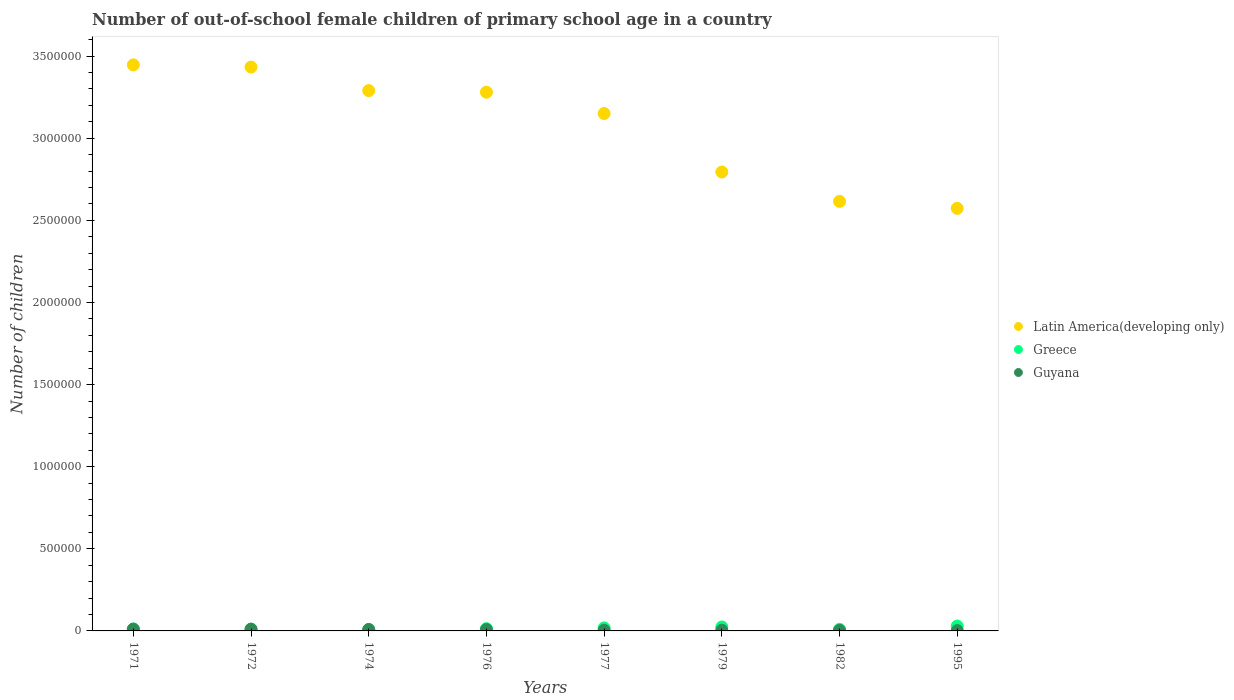Is the number of dotlines equal to the number of legend labels?
Offer a terse response. Yes. What is the number of out-of-school female children in Greece in 1971?
Keep it short and to the point. 1.16e+04. Across all years, what is the maximum number of out-of-school female children in Greece?
Ensure brevity in your answer.  2.95e+04. Across all years, what is the minimum number of out-of-school female children in Latin America(developing only)?
Provide a succinct answer. 2.57e+06. In which year was the number of out-of-school female children in Guyana maximum?
Your response must be concise. 1972. In which year was the number of out-of-school female children in Latin America(developing only) minimum?
Offer a terse response. 1995. What is the total number of out-of-school female children in Guyana in the graph?
Give a very brief answer. 5.31e+04. What is the difference between the number of out-of-school female children in Greece in 1977 and that in 1982?
Provide a short and direct response. 8815. What is the difference between the number of out-of-school female children in Guyana in 1995 and the number of out-of-school female children in Latin America(developing only) in 1977?
Your answer should be compact. -3.15e+06. What is the average number of out-of-school female children in Greece per year?
Your response must be concise. 1.56e+04. In the year 1977, what is the difference between the number of out-of-school female children in Greece and number of out-of-school female children in Latin America(developing only)?
Provide a short and direct response. -3.13e+06. What is the ratio of the number of out-of-school female children in Greece in 1974 to that in 1995?
Offer a very short reply. 0.25. Is the difference between the number of out-of-school female children in Greece in 1971 and 1972 greater than the difference between the number of out-of-school female children in Latin America(developing only) in 1971 and 1972?
Provide a short and direct response. No. What is the difference between the highest and the second highest number of out-of-school female children in Latin America(developing only)?
Make the answer very short. 1.34e+04. What is the difference between the highest and the lowest number of out-of-school female children in Latin America(developing only)?
Ensure brevity in your answer.  8.74e+05. Is the sum of the number of out-of-school female children in Greece in 1979 and 1982 greater than the maximum number of out-of-school female children in Guyana across all years?
Give a very brief answer. Yes. Is the number of out-of-school female children in Greece strictly less than the number of out-of-school female children in Guyana over the years?
Your answer should be compact. No. How many dotlines are there?
Your response must be concise. 3. What is the difference between two consecutive major ticks on the Y-axis?
Provide a short and direct response. 5.00e+05. Does the graph contain grids?
Your answer should be very brief. No. Where does the legend appear in the graph?
Offer a terse response. Center right. How many legend labels are there?
Provide a short and direct response. 3. How are the legend labels stacked?
Your answer should be compact. Vertical. What is the title of the graph?
Provide a short and direct response. Number of out-of-school female children of primary school age in a country. What is the label or title of the Y-axis?
Give a very brief answer. Number of children. What is the Number of children in Latin America(developing only) in 1971?
Your response must be concise. 3.45e+06. What is the Number of children of Greece in 1971?
Your answer should be compact. 1.16e+04. What is the Number of children of Guyana in 1971?
Your answer should be very brief. 1.09e+04. What is the Number of children in Latin America(developing only) in 1972?
Offer a very short reply. 3.43e+06. What is the Number of children in Greece in 1972?
Your answer should be very brief. 1.07e+04. What is the Number of children in Guyana in 1972?
Provide a succinct answer. 1.10e+04. What is the Number of children of Latin America(developing only) in 1974?
Offer a terse response. 3.29e+06. What is the Number of children in Greece in 1974?
Your response must be concise. 7336. What is the Number of children in Guyana in 1974?
Provide a short and direct response. 8910. What is the Number of children in Latin America(developing only) in 1976?
Your answer should be very brief. 3.28e+06. What is the Number of children of Greece in 1976?
Offer a terse response. 1.38e+04. What is the Number of children in Guyana in 1976?
Keep it short and to the point. 8456. What is the Number of children in Latin America(developing only) in 1977?
Give a very brief answer. 3.15e+06. What is the Number of children in Greece in 1977?
Keep it short and to the point. 1.83e+04. What is the Number of children of Guyana in 1977?
Keep it short and to the point. 4077. What is the Number of children in Latin America(developing only) in 1979?
Give a very brief answer. 2.79e+06. What is the Number of children in Greece in 1979?
Offer a terse response. 2.41e+04. What is the Number of children of Guyana in 1979?
Your response must be concise. 4353. What is the Number of children in Latin America(developing only) in 1982?
Provide a succinct answer. 2.62e+06. What is the Number of children of Greece in 1982?
Provide a succinct answer. 9447. What is the Number of children in Guyana in 1982?
Make the answer very short. 3656. What is the Number of children in Latin America(developing only) in 1995?
Make the answer very short. 2.57e+06. What is the Number of children in Greece in 1995?
Offer a very short reply. 2.95e+04. What is the Number of children of Guyana in 1995?
Give a very brief answer. 1838. Across all years, what is the maximum Number of children of Latin America(developing only)?
Make the answer very short. 3.45e+06. Across all years, what is the maximum Number of children of Greece?
Provide a succinct answer. 2.95e+04. Across all years, what is the maximum Number of children of Guyana?
Keep it short and to the point. 1.10e+04. Across all years, what is the minimum Number of children of Latin America(developing only)?
Offer a very short reply. 2.57e+06. Across all years, what is the minimum Number of children in Greece?
Your answer should be very brief. 7336. Across all years, what is the minimum Number of children in Guyana?
Keep it short and to the point. 1838. What is the total Number of children of Latin America(developing only) in the graph?
Your answer should be very brief. 2.46e+07. What is the total Number of children in Greece in the graph?
Provide a short and direct response. 1.25e+05. What is the total Number of children in Guyana in the graph?
Offer a very short reply. 5.31e+04. What is the difference between the Number of children of Latin America(developing only) in 1971 and that in 1972?
Offer a very short reply. 1.34e+04. What is the difference between the Number of children of Greece in 1971 and that in 1972?
Keep it short and to the point. 932. What is the difference between the Number of children in Guyana in 1971 and that in 1972?
Keep it short and to the point. -63. What is the difference between the Number of children of Latin America(developing only) in 1971 and that in 1974?
Your answer should be very brief. 1.57e+05. What is the difference between the Number of children of Greece in 1971 and that in 1974?
Offer a terse response. 4256. What is the difference between the Number of children of Guyana in 1971 and that in 1974?
Keep it short and to the point. 1980. What is the difference between the Number of children in Latin America(developing only) in 1971 and that in 1976?
Offer a very short reply. 1.66e+05. What is the difference between the Number of children of Greece in 1971 and that in 1976?
Ensure brevity in your answer.  -2198. What is the difference between the Number of children in Guyana in 1971 and that in 1976?
Offer a terse response. 2434. What is the difference between the Number of children of Latin America(developing only) in 1971 and that in 1977?
Your response must be concise. 2.96e+05. What is the difference between the Number of children of Greece in 1971 and that in 1977?
Offer a very short reply. -6670. What is the difference between the Number of children of Guyana in 1971 and that in 1977?
Make the answer very short. 6813. What is the difference between the Number of children in Latin America(developing only) in 1971 and that in 1979?
Your answer should be very brief. 6.53e+05. What is the difference between the Number of children in Greece in 1971 and that in 1979?
Keep it short and to the point. -1.25e+04. What is the difference between the Number of children in Guyana in 1971 and that in 1979?
Offer a very short reply. 6537. What is the difference between the Number of children in Latin America(developing only) in 1971 and that in 1982?
Make the answer very short. 8.31e+05. What is the difference between the Number of children of Greece in 1971 and that in 1982?
Provide a short and direct response. 2145. What is the difference between the Number of children of Guyana in 1971 and that in 1982?
Make the answer very short. 7234. What is the difference between the Number of children in Latin America(developing only) in 1971 and that in 1995?
Your answer should be compact. 8.74e+05. What is the difference between the Number of children in Greece in 1971 and that in 1995?
Ensure brevity in your answer.  -1.79e+04. What is the difference between the Number of children in Guyana in 1971 and that in 1995?
Provide a short and direct response. 9052. What is the difference between the Number of children of Latin America(developing only) in 1972 and that in 1974?
Make the answer very short. 1.43e+05. What is the difference between the Number of children of Greece in 1972 and that in 1974?
Your answer should be very brief. 3324. What is the difference between the Number of children in Guyana in 1972 and that in 1974?
Your answer should be compact. 2043. What is the difference between the Number of children in Latin America(developing only) in 1972 and that in 1976?
Your answer should be very brief. 1.53e+05. What is the difference between the Number of children of Greece in 1972 and that in 1976?
Provide a succinct answer. -3130. What is the difference between the Number of children in Guyana in 1972 and that in 1976?
Your response must be concise. 2497. What is the difference between the Number of children of Latin America(developing only) in 1972 and that in 1977?
Provide a succinct answer. 2.83e+05. What is the difference between the Number of children in Greece in 1972 and that in 1977?
Keep it short and to the point. -7602. What is the difference between the Number of children in Guyana in 1972 and that in 1977?
Give a very brief answer. 6876. What is the difference between the Number of children of Latin America(developing only) in 1972 and that in 1979?
Give a very brief answer. 6.39e+05. What is the difference between the Number of children of Greece in 1972 and that in 1979?
Offer a terse response. -1.35e+04. What is the difference between the Number of children in Guyana in 1972 and that in 1979?
Ensure brevity in your answer.  6600. What is the difference between the Number of children in Latin America(developing only) in 1972 and that in 1982?
Keep it short and to the point. 8.18e+05. What is the difference between the Number of children of Greece in 1972 and that in 1982?
Ensure brevity in your answer.  1213. What is the difference between the Number of children in Guyana in 1972 and that in 1982?
Ensure brevity in your answer.  7297. What is the difference between the Number of children of Latin America(developing only) in 1972 and that in 1995?
Your response must be concise. 8.60e+05. What is the difference between the Number of children in Greece in 1972 and that in 1995?
Make the answer very short. -1.88e+04. What is the difference between the Number of children in Guyana in 1972 and that in 1995?
Offer a terse response. 9115. What is the difference between the Number of children in Latin America(developing only) in 1974 and that in 1976?
Give a very brief answer. 9686. What is the difference between the Number of children of Greece in 1974 and that in 1976?
Give a very brief answer. -6454. What is the difference between the Number of children in Guyana in 1974 and that in 1976?
Your answer should be very brief. 454. What is the difference between the Number of children in Latin America(developing only) in 1974 and that in 1977?
Make the answer very short. 1.39e+05. What is the difference between the Number of children in Greece in 1974 and that in 1977?
Provide a short and direct response. -1.09e+04. What is the difference between the Number of children of Guyana in 1974 and that in 1977?
Give a very brief answer. 4833. What is the difference between the Number of children in Latin America(developing only) in 1974 and that in 1979?
Your response must be concise. 4.96e+05. What is the difference between the Number of children of Greece in 1974 and that in 1979?
Make the answer very short. -1.68e+04. What is the difference between the Number of children in Guyana in 1974 and that in 1979?
Give a very brief answer. 4557. What is the difference between the Number of children of Latin America(developing only) in 1974 and that in 1982?
Your response must be concise. 6.75e+05. What is the difference between the Number of children in Greece in 1974 and that in 1982?
Your response must be concise. -2111. What is the difference between the Number of children of Guyana in 1974 and that in 1982?
Offer a very short reply. 5254. What is the difference between the Number of children in Latin America(developing only) in 1974 and that in 1995?
Offer a terse response. 7.17e+05. What is the difference between the Number of children in Greece in 1974 and that in 1995?
Give a very brief answer. -2.22e+04. What is the difference between the Number of children of Guyana in 1974 and that in 1995?
Your answer should be very brief. 7072. What is the difference between the Number of children of Latin America(developing only) in 1976 and that in 1977?
Your answer should be very brief. 1.30e+05. What is the difference between the Number of children of Greece in 1976 and that in 1977?
Provide a short and direct response. -4472. What is the difference between the Number of children of Guyana in 1976 and that in 1977?
Make the answer very short. 4379. What is the difference between the Number of children in Latin America(developing only) in 1976 and that in 1979?
Make the answer very short. 4.86e+05. What is the difference between the Number of children of Greece in 1976 and that in 1979?
Your response must be concise. -1.03e+04. What is the difference between the Number of children in Guyana in 1976 and that in 1979?
Your answer should be compact. 4103. What is the difference between the Number of children in Latin America(developing only) in 1976 and that in 1982?
Provide a succinct answer. 6.65e+05. What is the difference between the Number of children in Greece in 1976 and that in 1982?
Your answer should be very brief. 4343. What is the difference between the Number of children in Guyana in 1976 and that in 1982?
Keep it short and to the point. 4800. What is the difference between the Number of children of Latin America(developing only) in 1976 and that in 1995?
Offer a terse response. 7.07e+05. What is the difference between the Number of children in Greece in 1976 and that in 1995?
Your answer should be compact. -1.57e+04. What is the difference between the Number of children of Guyana in 1976 and that in 1995?
Your response must be concise. 6618. What is the difference between the Number of children in Latin America(developing only) in 1977 and that in 1979?
Give a very brief answer. 3.56e+05. What is the difference between the Number of children in Greece in 1977 and that in 1979?
Your answer should be very brief. -5863. What is the difference between the Number of children of Guyana in 1977 and that in 1979?
Keep it short and to the point. -276. What is the difference between the Number of children in Latin America(developing only) in 1977 and that in 1982?
Ensure brevity in your answer.  5.35e+05. What is the difference between the Number of children in Greece in 1977 and that in 1982?
Offer a terse response. 8815. What is the difference between the Number of children in Guyana in 1977 and that in 1982?
Provide a short and direct response. 421. What is the difference between the Number of children of Latin America(developing only) in 1977 and that in 1995?
Give a very brief answer. 5.78e+05. What is the difference between the Number of children in Greece in 1977 and that in 1995?
Provide a short and direct response. -1.12e+04. What is the difference between the Number of children of Guyana in 1977 and that in 1995?
Ensure brevity in your answer.  2239. What is the difference between the Number of children in Latin America(developing only) in 1979 and that in 1982?
Your response must be concise. 1.79e+05. What is the difference between the Number of children of Greece in 1979 and that in 1982?
Keep it short and to the point. 1.47e+04. What is the difference between the Number of children of Guyana in 1979 and that in 1982?
Your answer should be very brief. 697. What is the difference between the Number of children of Latin America(developing only) in 1979 and that in 1995?
Your response must be concise. 2.21e+05. What is the difference between the Number of children of Greece in 1979 and that in 1995?
Offer a very short reply. -5365. What is the difference between the Number of children of Guyana in 1979 and that in 1995?
Give a very brief answer. 2515. What is the difference between the Number of children of Latin America(developing only) in 1982 and that in 1995?
Provide a short and direct response. 4.25e+04. What is the difference between the Number of children in Greece in 1982 and that in 1995?
Ensure brevity in your answer.  -2.00e+04. What is the difference between the Number of children in Guyana in 1982 and that in 1995?
Provide a succinct answer. 1818. What is the difference between the Number of children of Latin America(developing only) in 1971 and the Number of children of Greece in 1972?
Provide a short and direct response. 3.44e+06. What is the difference between the Number of children in Latin America(developing only) in 1971 and the Number of children in Guyana in 1972?
Your response must be concise. 3.44e+06. What is the difference between the Number of children of Greece in 1971 and the Number of children of Guyana in 1972?
Your response must be concise. 639. What is the difference between the Number of children in Latin America(developing only) in 1971 and the Number of children in Greece in 1974?
Offer a very short reply. 3.44e+06. What is the difference between the Number of children in Latin America(developing only) in 1971 and the Number of children in Guyana in 1974?
Ensure brevity in your answer.  3.44e+06. What is the difference between the Number of children of Greece in 1971 and the Number of children of Guyana in 1974?
Provide a succinct answer. 2682. What is the difference between the Number of children in Latin America(developing only) in 1971 and the Number of children in Greece in 1976?
Your response must be concise. 3.43e+06. What is the difference between the Number of children in Latin America(developing only) in 1971 and the Number of children in Guyana in 1976?
Offer a terse response. 3.44e+06. What is the difference between the Number of children of Greece in 1971 and the Number of children of Guyana in 1976?
Provide a short and direct response. 3136. What is the difference between the Number of children in Latin America(developing only) in 1971 and the Number of children in Greece in 1977?
Provide a succinct answer. 3.43e+06. What is the difference between the Number of children in Latin America(developing only) in 1971 and the Number of children in Guyana in 1977?
Keep it short and to the point. 3.44e+06. What is the difference between the Number of children in Greece in 1971 and the Number of children in Guyana in 1977?
Your response must be concise. 7515. What is the difference between the Number of children in Latin America(developing only) in 1971 and the Number of children in Greece in 1979?
Your answer should be compact. 3.42e+06. What is the difference between the Number of children in Latin America(developing only) in 1971 and the Number of children in Guyana in 1979?
Provide a succinct answer. 3.44e+06. What is the difference between the Number of children in Greece in 1971 and the Number of children in Guyana in 1979?
Keep it short and to the point. 7239. What is the difference between the Number of children in Latin America(developing only) in 1971 and the Number of children in Greece in 1982?
Offer a very short reply. 3.44e+06. What is the difference between the Number of children in Latin America(developing only) in 1971 and the Number of children in Guyana in 1982?
Give a very brief answer. 3.44e+06. What is the difference between the Number of children of Greece in 1971 and the Number of children of Guyana in 1982?
Provide a succinct answer. 7936. What is the difference between the Number of children of Latin America(developing only) in 1971 and the Number of children of Greece in 1995?
Make the answer very short. 3.42e+06. What is the difference between the Number of children in Latin America(developing only) in 1971 and the Number of children in Guyana in 1995?
Your answer should be very brief. 3.45e+06. What is the difference between the Number of children in Greece in 1971 and the Number of children in Guyana in 1995?
Your answer should be very brief. 9754. What is the difference between the Number of children of Latin America(developing only) in 1972 and the Number of children of Greece in 1974?
Ensure brevity in your answer.  3.43e+06. What is the difference between the Number of children of Latin America(developing only) in 1972 and the Number of children of Guyana in 1974?
Offer a very short reply. 3.42e+06. What is the difference between the Number of children in Greece in 1972 and the Number of children in Guyana in 1974?
Ensure brevity in your answer.  1750. What is the difference between the Number of children in Latin America(developing only) in 1972 and the Number of children in Greece in 1976?
Offer a very short reply. 3.42e+06. What is the difference between the Number of children of Latin America(developing only) in 1972 and the Number of children of Guyana in 1976?
Ensure brevity in your answer.  3.43e+06. What is the difference between the Number of children of Greece in 1972 and the Number of children of Guyana in 1976?
Provide a short and direct response. 2204. What is the difference between the Number of children of Latin America(developing only) in 1972 and the Number of children of Greece in 1977?
Your answer should be compact. 3.42e+06. What is the difference between the Number of children in Latin America(developing only) in 1972 and the Number of children in Guyana in 1977?
Keep it short and to the point. 3.43e+06. What is the difference between the Number of children in Greece in 1972 and the Number of children in Guyana in 1977?
Keep it short and to the point. 6583. What is the difference between the Number of children in Latin America(developing only) in 1972 and the Number of children in Greece in 1979?
Offer a terse response. 3.41e+06. What is the difference between the Number of children in Latin America(developing only) in 1972 and the Number of children in Guyana in 1979?
Ensure brevity in your answer.  3.43e+06. What is the difference between the Number of children in Greece in 1972 and the Number of children in Guyana in 1979?
Provide a short and direct response. 6307. What is the difference between the Number of children in Latin America(developing only) in 1972 and the Number of children in Greece in 1982?
Offer a terse response. 3.42e+06. What is the difference between the Number of children in Latin America(developing only) in 1972 and the Number of children in Guyana in 1982?
Provide a succinct answer. 3.43e+06. What is the difference between the Number of children in Greece in 1972 and the Number of children in Guyana in 1982?
Your answer should be very brief. 7004. What is the difference between the Number of children of Latin America(developing only) in 1972 and the Number of children of Greece in 1995?
Provide a succinct answer. 3.40e+06. What is the difference between the Number of children in Latin America(developing only) in 1972 and the Number of children in Guyana in 1995?
Provide a succinct answer. 3.43e+06. What is the difference between the Number of children in Greece in 1972 and the Number of children in Guyana in 1995?
Your response must be concise. 8822. What is the difference between the Number of children of Latin America(developing only) in 1974 and the Number of children of Greece in 1976?
Give a very brief answer. 3.28e+06. What is the difference between the Number of children in Latin America(developing only) in 1974 and the Number of children in Guyana in 1976?
Your answer should be compact. 3.28e+06. What is the difference between the Number of children of Greece in 1974 and the Number of children of Guyana in 1976?
Offer a terse response. -1120. What is the difference between the Number of children of Latin America(developing only) in 1974 and the Number of children of Greece in 1977?
Ensure brevity in your answer.  3.27e+06. What is the difference between the Number of children of Latin America(developing only) in 1974 and the Number of children of Guyana in 1977?
Your answer should be compact. 3.29e+06. What is the difference between the Number of children in Greece in 1974 and the Number of children in Guyana in 1977?
Provide a succinct answer. 3259. What is the difference between the Number of children in Latin America(developing only) in 1974 and the Number of children in Greece in 1979?
Your answer should be very brief. 3.27e+06. What is the difference between the Number of children in Latin America(developing only) in 1974 and the Number of children in Guyana in 1979?
Provide a succinct answer. 3.29e+06. What is the difference between the Number of children in Greece in 1974 and the Number of children in Guyana in 1979?
Provide a short and direct response. 2983. What is the difference between the Number of children of Latin America(developing only) in 1974 and the Number of children of Greece in 1982?
Provide a short and direct response. 3.28e+06. What is the difference between the Number of children of Latin America(developing only) in 1974 and the Number of children of Guyana in 1982?
Offer a very short reply. 3.29e+06. What is the difference between the Number of children in Greece in 1974 and the Number of children in Guyana in 1982?
Your answer should be compact. 3680. What is the difference between the Number of children in Latin America(developing only) in 1974 and the Number of children in Greece in 1995?
Offer a very short reply. 3.26e+06. What is the difference between the Number of children in Latin America(developing only) in 1974 and the Number of children in Guyana in 1995?
Keep it short and to the point. 3.29e+06. What is the difference between the Number of children in Greece in 1974 and the Number of children in Guyana in 1995?
Your answer should be compact. 5498. What is the difference between the Number of children in Latin America(developing only) in 1976 and the Number of children in Greece in 1977?
Provide a short and direct response. 3.26e+06. What is the difference between the Number of children of Latin America(developing only) in 1976 and the Number of children of Guyana in 1977?
Make the answer very short. 3.28e+06. What is the difference between the Number of children of Greece in 1976 and the Number of children of Guyana in 1977?
Your answer should be compact. 9713. What is the difference between the Number of children of Latin America(developing only) in 1976 and the Number of children of Greece in 1979?
Keep it short and to the point. 3.26e+06. What is the difference between the Number of children of Latin America(developing only) in 1976 and the Number of children of Guyana in 1979?
Your answer should be very brief. 3.28e+06. What is the difference between the Number of children of Greece in 1976 and the Number of children of Guyana in 1979?
Provide a short and direct response. 9437. What is the difference between the Number of children in Latin America(developing only) in 1976 and the Number of children in Greece in 1982?
Give a very brief answer. 3.27e+06. What is the difference between the Number of children of Latin America(developing only) in 1976 and the Number of children of Guyana in 1982?
Keep it short and to the point. 3.28e+06. What is the difference between the Number of children in Greece in 1976 and the Number of children in Guyana in 1982?
Offer a very short reply. 1.01e+04. What is the difference between the Number of children in Latin America(developing only) in 1976 and the Number of children in Greece in 1995?
Your response must be concise. 3.25e+06. What is the difference between the Number of children of Latin America(developing only) in 1976 and the Number of children of Guyana in 1995?
Ensure brevity in your answer.  3.28e+06. What is the difference between the Number of children of Greece in 1976 and the Number of children of Guyana in 1995?
Provide a succinct answer. 1.20e+04. What is the difference between the Number of children of Latin America(developing only) in 1977 and the Number of children of Greece in 1979?
Your answer should be very brief. 3.13e+06. What is the difference between the Number of children of Latin America(developing only) in 1977 and the Number of children of Guyana in 1979?
Provide a succinct answer. 3.15e+06. What is the difference between the Number of children in Greece in 1977 and the Number of children in Guyana in 1979?
Make the answer very short. 1.39e+04. What is the difference between the Number of children of Latin America(developing only) in 1977 and the Number of children of Greece in 1982?
Ensure brevity in your answer.  3.14e+06. What is the difference between the Number of children in Latin America(developing only) in 1977 and the Number of children in Guyana in 1982?
Your answer should be very brief. 3.15e+06. What is the difference between the Number of children of Greece in 1977 and the Number of children of Guyana in 1982?
Your response must be concise. 1.46e+04. What is the difference between the Number of children in Latin America(developing only) in 1977 and the Number of children in Greece in 1995?
Your answer should be very brief. 3.12e+06. What is the difference between the Number of children in Latin America(developing only) in 1977 and the Number of children in Guyana in 1995?
Offer a terse response. 3.15e+06. What is the difference between the Number of children of Greece in 1977 and the Number of children of Guyana in 1995?
Make the answer very short. 1.64e+04. What is the difference between the Number of children of Latin America(developing only) in 1979 and the Number of children of Greece in 1982?
Provide a short and direct response. 2.78e+06. What is the difference between the Number of children in Latin America(developing only) in 1979 and the Number of children in Guyana in 1982?
Provide a short and direct response. 2.79e+06. What is the difference between the Number of children in Greece in 1979 and the Number of children in Guyana in 1982?
Offer a very short reply. 2.05e+04. What is the difference between the Number of children in Latin America(developing only) in 1979 and the Number of children in Greece in 1995?
Keep it short and to the point. 2.76e+06. What is the difference between the Number of children in Latin America(developing only) in 1979 and the Number of children in Guyana in 1995?
Your response must be concise. 2.79e+06. What is the difference between the Number of children of Greece in 1979 and the Number of children of Guyana in 1995?
Make the answer very short. 2.23e+04. What is the difference between the Number of children of Latin America(developing only) in 1982 and the Number of children of Greece in 1995?
Your answer should be compact. 2.59e+06. What is the difference between the Number of children of Latin America(developing only) in 1982 and the Number of children of Guyana in 1995?
Provide a succinct answer. 2.61e+06. What is the difference between the Number of children of Greece in 1982 and the Number of children of Guyana in 1995?
Your response must be concise. 7609. What is the average Number of children in Latin America(developing only) per year?
Your answer should be compact. 3.07e+06. What is the average Number of children in Greece per year?
Provide a short and direct response. 1.56e+04. What is the average Number of children in Guyana per year?
Your response must be concise. 6641.62. In the year 1971, what is the difference between the Number of children in Latin America(developing only) and Number of children in Greece?
Your answer should be compact. 3.44e+06. In the year 1971, what is the difference between the Number of children in Latin America(developing only) and Number of children in Guyana?
Provide a succinct answer. 3.44e+06. In the year 1971, what is the difference between the Number of children in Greece and Number of children in Guyana?
Ensure brevity in your answer.  702. In the year 1972, what is the difference between the Number of children in Latin America(developing only) and Number of children in Greece?
Make the answer very short. 3.42e+06. In the year 1972, what is the difference between the Number of children in Latin America(developing only) and Number of children in Guyana?
Offer a very short reply. 3.42e+06. In the year 1972, what is the difference between the Number of children of Greece and Number of children of Guyana?
Ensure brevity in your answer.  -293. In the year 1974, what is the difference between the Number of children of Latin America(developing only) and Number of children of Greece?
Make the answer very short. 3.28e+06. In the year 1974, what is the difference between the Number of children in Latin America(developing only) and Number of children in Guyana?
Provide a short and direct response. 3.28e+06. In the year 1974, what is the difference between the Number of children in Greece and Number of children in Guyana?
Offer a terse response. -1574. In the year 1976, what is the difference between the Number of children of Latin America(developing only) and Number of children of Greece?
Your answer should be very brief. 3.27e+06. In the year 1976, what is the difference between the Number of children in Latin America(developing only) and Number of children in Guyana?
Your answer should be compact. 3.27e+06. In the year 1976, what is the difference between the Number of children in Greece and Number of children in Guyana?
Your answer should be very brief. 5334. In the year 1977, what is the difference between the Number of children of Latin America(developing only) and Number of children of Greece?
Offer a very short reply. 3.13e+06. In the year 1977, what is the difference between the Number of children in Latin America(developing only) and Number of children in Guyana?
Offer a terse response. 3.15e+06. In the year 1977, what is the difference between the Number of children in Greece and Number of children in Guyana?
Your answer should be very brief. 1.42e+04. In the year 1979, what is the difference between the Number of children of Latin America(developing only) and Number of children of Greece?
Offer a very short reply. 2.77e+06. In the year 1979, what is the difference between the Number of children in Latin America(developing only) and Number of children in Guyana?
Ensure brevity in your answer.  2.79e+06. In the year 1979, what is the difference between the Number of children of Greece and Number of children of Guyana?
Provide a short and direct response. 1.98e+04. In the year 1982, what is the difference between the Number of children in Latin America(developing only) and Number of children in Greece?
Offer a terse response. 2.61e+06. In the year 1982, what is the difference between the Number of children of Latin America(developing only) and Number of children of Guyana?
Make the answer very short. 2.61e+06. In the year 1982, what is the difference between the Number of children of Greece and Number of children of Guyana?
Your answer should be very brief. 5791. In the year 1995, what is the difference between the Number of children of Latin America(developing only) and Number of children of Greece?
Offer a very short reply. 2.54e+06. In the year 1995, what is the difference between the Number of children in Latin America(developing only) and Number of children in Guyana?
Give a very brief answer. 2.57e+06. In the year 1995, what is the difference between the Number of children of Greece and Number of children of Guyana?
Keep it short and to the point. 2.77e+04. What is the ratio of the Number of children of Greece in 1971 to that in 1972?
Make the answer very short. 1.09. What is the ratio of the Number of children in Latin America(developing only) in 1971 to that in 1974?
Give a very brief answer. 1.05. What is the ratio of the Number of children of Greece in 1971 to that in 1974?
Offer a terse response. 1.58. What is the ratio of the Number of children in Guyana in 1971 to that in 1974?
Your answer should be very brief. 1.22. What is the ratio of the Number of children in Latin America(developing only) in 1971 to that in 1976?
Offer a very short reply. 1.05. What is the ratio of the Number of children in Greece in 1971 to that in 1976?
Your answer should be compact. 0.84. What is the ratio of the Number of children of Guyana in 1971 to that in 1976?
Your response must be concise. 1.29. What is the ratio of the Number of children in Latin America(developing only) in 1971 to that in 1977?
Offer a terse response. 1.09. What is the ratio of the Number of children in Greece in 1971 to that in 1977?
Ensure brevity in your answer.  0.63. What is the ratio of the Number of children in Guyana in 1971 to that in 1977?
Provide a succinct answer. 2.67. What is the ratio of the Number of children in Latin America(developing only) in 1971 to that in 1979?
Ensure brevity in your answer.  1.23. What is the ratio of the Number of children in Greece in 1971 to that in 1979?
Keep it short and to the point. 0.48. What is the ratio of the Number of children of Guyana in 1971 to that in 1979?
Offer a very short reply. 2.5. What is the ratio of the Number of children in Latin America(developing only) in 1971 to that in 1982?
Give a very brief answer. 1.32. What is the ratio of the Number of children in Greece in 1971 to that in 1982?
Your response must be concise. 1.23. What is the ratio of the Number of children in Guyana in 1971 to that in 1982?
Your response must be concise. 2.98. What is the ratio of the Number of children of Latin America(developing only) in 1971 to that in 1995?
Ensure brevity in your answer.  1.34. What is the ratio of the Number of children of Greece in 1971 to that in 1995?
Your answer should be compact. 0.39. What is the ratio of the Number of children in Guyana in 1971 to that in 1995?
Your answer should be very brief. 5.92. What is the ratio of the Number of children in Latin America(developing only) in 1972 to that in 1974?
Give a very brief answer. 1.04. What is the ratio of the Number of children in Greece in 1972 to that in 1974?
Offer a terse response. 1.45. What is the ratio of the Number of children of Guyana in 1972 to that in 1974?
Ensure brevity in your answer.  1.23. What is the ratio of the Number of children in Latin America(developing only) in 1972 to that in 1976?
Your response must be concise. 1.05. What is the ratio of the Number of children in Greece in 1972 to that in 1976?
Offer a very short reply. 0.77. What is the ratio of the Number of children in Guyana in 1972 to that in 1976?
Your response must be concise. 1.3. What is the ratio of the Number of children in Latin America(developing only) in 1972 to that in 1977?
Offer a very short reply. 1.09. What is the ratio of the Number of children in Greece in 1972 to that in 1977?
Your response must be concise. 0.58. What is the ratio of the Number of children of Guyana in 1972 to that in 1977?
Offer a very short reply. 2.69. What is the ratio of the Number of children of Latin America(developing only) in 1972 to that in 1979?
Your answer should be compact. 1.23. What is the ratio of the Number of children of Greece in 1972 to that in 1979?
Your answer should be very brief. 0.44. What is the ratio of the Number of children of Guyana in 1972 to that in 1979?
Offer a terse response. 2.52. What is the ratio of the Number of children in Latin America(developing only) in 1972 to that in 1982?
Provide a succinct answer. 1.31. What is the ratio of the Number of children in Greece in 1972 to that in 1982?
Your answer should be very brief. 1.13. What is the ratio of the Number of children in Guyana in 1972 to that in 1982?
Keep it short and to the point. 3. What is the ratio of the Number of children of Latin America(developing only) in 1972 to that in 1995?
Your response must be concise. 1.33. What is the ratio of the Number of children in Greece in 1972 to that in 1995?
Your answer should be very brief. 0.36. What is the ratio of the Number of children of Guyana in 1972 to that in 1995?
Give a very brief answer. 5.96. What is the ratio of the Number of children in Greece in 1974 to that in 1976?
Your answer should be compact. 0.53. What is the ratio of the Number of children in Guyana in 1974 to that in 1976?
Your answer should be compact. 1.05. What is the ratio of the Number of children of Latin America(developing only) in 1974 to that in 1977?
Provide a short and direct response. 1.04. What is the ratio of the Number of children in Greece in 1974 to that in 1977?
Offer a terse response. 0.4. What is the ratio of the Number of children in Guyana in 1974 to that in 1977?
Provide a succinct answer. 2.19. What is the ratio of the Number of children of Latin America(developing only) in 1974 to that in 1979?
Provide a succinct answer. 1.18. What is the ratio of the Number of children in Greece in 1974 to that in 1979?
Keep it short and to the point. 0.3. What is the ratio of the Number of children of Guyana in 1974 to that in 1979?
Give a very brief answer. 2.05. What is the ratio of the Number of children of Latin America(developing only) in 1974 to that in 1982?
Your answer should be very brief. 1.26. What is the ratio of the Number of children of Greece in 1974 to that in 1982?
Provide a short and direct response. 0.78. What is the ratio of the Number of children in Guyana in 1974 to that in 1982?
Offer a terse response. 2.44. What is the ratio of the Number of children in Latin America(developing only) in 1974 to that in 1995?
Your answer should be compact. 1.28. What is the ratio of the Number of children of Greece in 1974 to that in 1995?
Your response must be concise. 0.25. What is the ratio of the Number of children of Guyana in 1974 to that in 1995?
Your answer should be very brief. 4.85. What is the ratio of the Number of children in Latin America(developing only) in 1976 to that in 1977?
Provide a short and direct response. 1.04. What is the ratio of the Number of children of Greece in 1976 to that in 1977?
Provide a succinct answer. 0.76. What is the ratio of the Number of children in Guyana in 1976 to that in 1977?
Give a very brief answer. 2.07. What is the ratio of the Number of children in Latin America(developing only) in 1976 to that in 1979?
Your answer should be very brief. 1.17. What is the ratio of the Number of children in Greece in 1976 to that in 1979?
Offer a terse response. 0.57. What is the ratio of the Number of children in Guyana in 1976 to that in 1979?
Keep it short and to the point. 1.94. What is the ratio of the Number of children in Latin America(developing only) in 1976 to that in 1982?
Keep it short and to the point. 1.25. What is the ratio of the Number of children in Greece in 1976 to that in 1982?
Offer a very short reply. 1.46. What is the ratio of the Number of children in Guyana in 1976 to that in 1982?
Provide a succinct answer. 2.31. What is the ratio of the Number of children of Latin America(developing only) in 1976 to that in 1995?
Keep it short and to the point. 1.27. What is the ratio of the Number of children of Greece in 1976 to that in 1995?
Keep it short and to the point. 0.47. What is the ratio of the Number of children in Guyana in 1976 to that in 1995?
Provide a succinct answer. 4.6. What is the ratio of the Number of children of Latin America(developing only) in 1977 to that in 1979?
Make the answer very short. 1.13. What is the ratio of the Number of children in Greece in 1977 to that in 1979?
Give a very brief answer. 0.76. What is the ratio of the Number of children in Guyana in 1977 to that in 1979?
Ensure brevity in your answer.  0.94. What is the ratio of the Number of children in Latin America(developing only) in 1977 to that in 1982?
Your response must be concise. 1.2. What is the ratio of the Number of children of Greece in 1977 to that in 1982?
Your answer should be compact. 1.93. What is the ratio of the Number of children of Guyana in 1977 to that in 1982?
Ensure brevity in your answer.  1.12. What is the ratio of the Number of children in Latin America(developing only) in 1977 to that in 1995?
Your answer should be very brief. 1.22. What is the ratio of the Number of children in Greece in 1977 to that in 1995?
Your answer should be compact. 0.62. What is the ratio of the Number of children in Guyana in 1977 to that in 1995?
Your response must be concise. 2.22. What is the ratio of the Number of children of Latin America(developing only) in 1979 to that in 1982?
Offer a very short reply. 1.07. What is the ratio of the Number of children in Greece in 1979 to that in 1982?
Give a very brief answer. 2.55. What is the ratio of the Number of children of Guyana in 1979 to that in 1982?
Provide a short and direct response. 1.19. What is the ratio of the Number of children of Latin America(developing only) in 1979 to that in 1995?
Offer a terse response. 1.09. What is the ratio of the Number of children of Greece in 1979 to that in 1995?
Offer a terse response. 0.82. What is the ratio of the Number of children in Guyana in 1979 to that in 1995?
Your response must be concise. 2.37. What is the ratio of the Number of children of Latin America(developing only) in 1982 to that in 1995?
Make the answer very short. 1.02. What is the ratio of the Number of children of Greece in 1982 to that in 1995?
Make the answer very short. 0.32. What is the ratio of the Number of children of Guyana in 1982 to that in 1995?
Keep it short and to the point. 1.99. What is the difference between the highest and the second highest Number of children of Latin America(developing only)?
Give a very brief answer. 1.34e+04. What is the difference between the highest and the second highest Number of children in Greece?
Offer a very short reply. 5365. What is the difference between the highest and the lowest Number of children in Latin America(developing only)?
Provide a short and direct response. 8.74e+05. What is the difference between the highest and the lowest Number of children of Greece?
Provide a short and direct response. 2.22e+04. What is the difference between the highest and the lowest Number of children of Guyana?
Ensure brevity in your answer.  9115. 